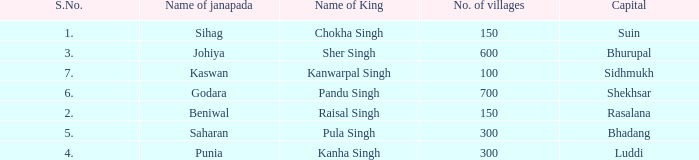Can you give me this table as a dict? {'header': ['S.No.', 'Name of janapada', 'Name of King', 'No. of villages', 'Capital'], 'rows': [['1.', 'Sihag', 'Chokha Singh', '150', 'Suin'], ['3.', 'Johiya', 'Sher Singh', '600', 'Bhurupal'], ['7.', 'Kaswan', 'Kanwarpal Singh', '100', 'Sidhmukh'], ['6.', 'Godara', 'Pandu Singh', '700', 'Shekhsar'], ['2.', 'Beniwal', 'Raisal Singh', '150', 'Rasalana'], ['5.', 'Saharan', 'Pula Singh', '300', 'Bhadang'], ['4.', 'Punia', 'Kanha Singh', '300', 'Luddi']]} What capital has an S.Number under 7, and a Name of janapada of Punia? Luddi. 